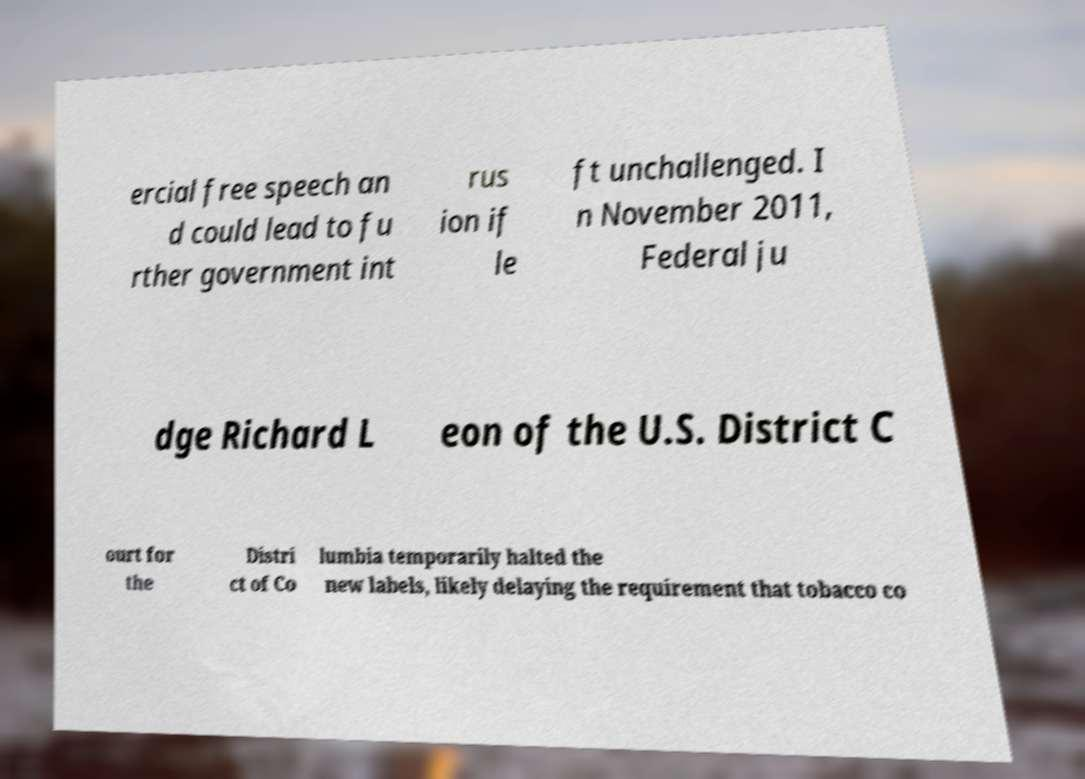Could you assist in decoding the text presented in this image and type it out clearly? ercial free speech an d could lead to fu rther government int rus ion if le ft unchallenged. I n November 2011, Federal ju dge Richard L eon of the U.S. District C ourt for the Distri ct of Co lumbia temporarily halted the new labels, likely delaying the requirement that tobacco co 